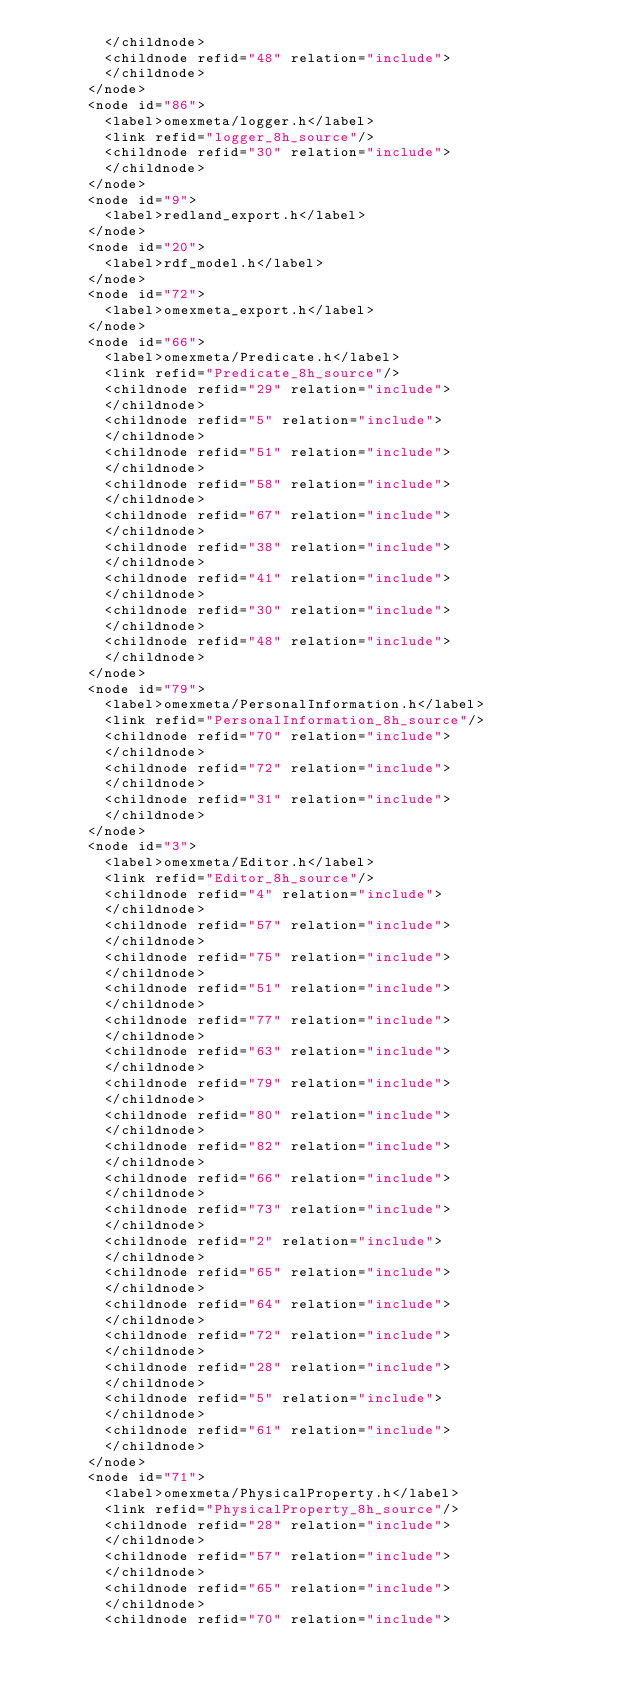Convert code to text. <code><loc_0><loc_0><loc_500><loc_500><_XML_>        </childnode>
        <childnode refid="48" relation="include">
        </childnode>
      </node>
      <node id="86">
        <label>omexmeta/logger.h</label>
        <link refid="logger_8h_source"/>
        <childnode refid="30" relation="include">
        </childnode>
      </node>
      <node id="9">
        <label>redland_export.h</label>
      </node>
      <node id="20">
        <label>rdf_model.h</label>
      </node>
      <node id="72">
        <label>omexmeta_export.h</label>
      </node>
      <node id="66">
        <label>omexmeta/Predicate.h</label>
        <link refid="Predicate_8h_source"/>
        <childnode refid="29" relation="include">
        </childnode>
        <childnode refid="5" relation="include">
        </childnode>
        <childnode refid="51" relation="include">
        </childnode>
        <childnode refid="58" relation="include">
        </childnode>
        <childnode refid="67" relation="include">
        </childnode>
        <childnode refid="38" relation="include">
        </childnode>
        <childnode refid="41" relation="include">
        </childnode>
        <childnode refid="30" relation="include">
        </childnode>
        <childnode refid="48" relation="include">
        </childnode>
      </node>
      <node id="79">
        <label>omexmeta/PersonalInformation.h</label>
        <link refid="PersonalInformation_8h_source"/>
        <childnode refid="70" relation="include">
        </childnode>
        <childnode refid="72" relation="include">
        </childnode>
        <childnode refid="31" relation="include">
        </childnode>
      </node>
      <node id="3">
        <label>omexmeta/Editor.h</label>
        <link refid="Editor_8h_source"/>
        <childnode refid="4" relation="include">
        </childnode>
        <childnode refid="57" relation="include">
        </childnode>
        <childnode refid="75" relation="include">
        </childnode>
        <childnode refid="51" relation="include">
        </childnode>
        <childnode refid="77" relation="include">
        </childnode>
        <childnode refid="63" relation="include">
        </childnode>
        <childnode refid="79" relation="include">
        </childnode>
        <childnode refid="80" relation="include">
        </childnode>
        <childnode refid="82" relation="include">
        </childnode>
        <childnode refid="66" relation="include">
        </childnode>
        <childnode refid="73" relation="include">
        </childnode>
        <childnode refid="2" relation="include">
        </childnode>
        <childnode refid="65" relation="include">
        </childnode>
        <childnode refid="64" relation="include">
        </childnode>
        <childnode refid="72" relation="include">
        </childnode>
        <childnode refid="28" relation="include">
        </childnode>
        <childnode refid="5" relation="include">
        </childnode>
        <childnode refid="61" relation="include">
        </childnode>
      </node>
      <node id="71">
        <label>omexmeta/PhysicalProperty.h</label>
        <link refid="PhysicalProperty_8h_source"/>
        <childnode refid="28" relation="include">
        </childnode>
        <childnode refid="57" relation="include">
        </childnode>
        <childnode refid="65" relation="include">
        </childnode>
        <childnode refid="70" relation="include"></code> 